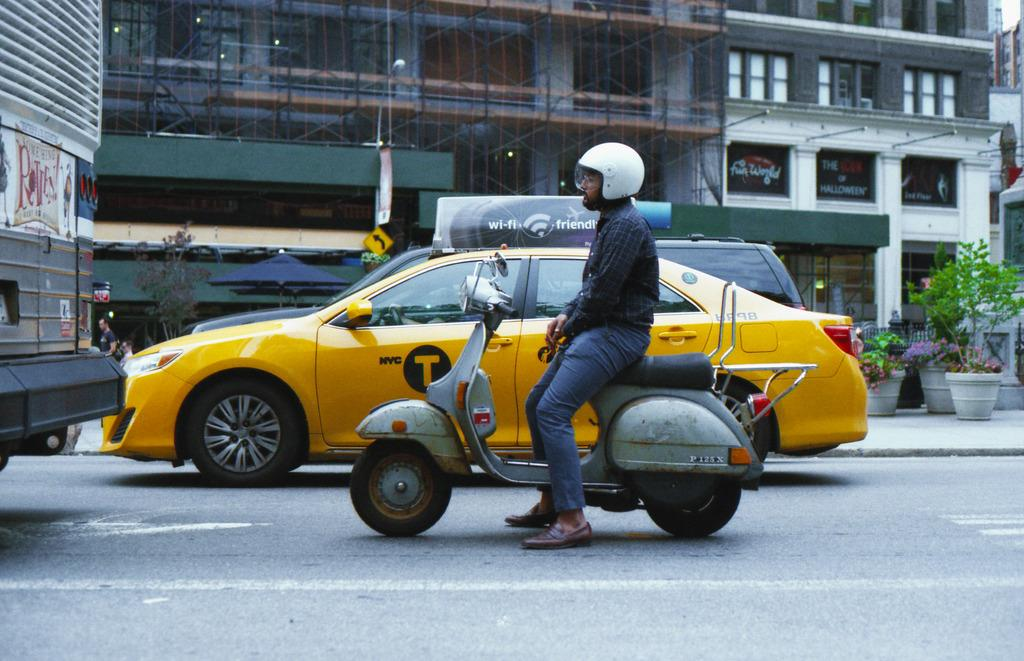<image>
Present a compact description of the photo's key features. A taxi with a sign on top that says wifi friendly. 